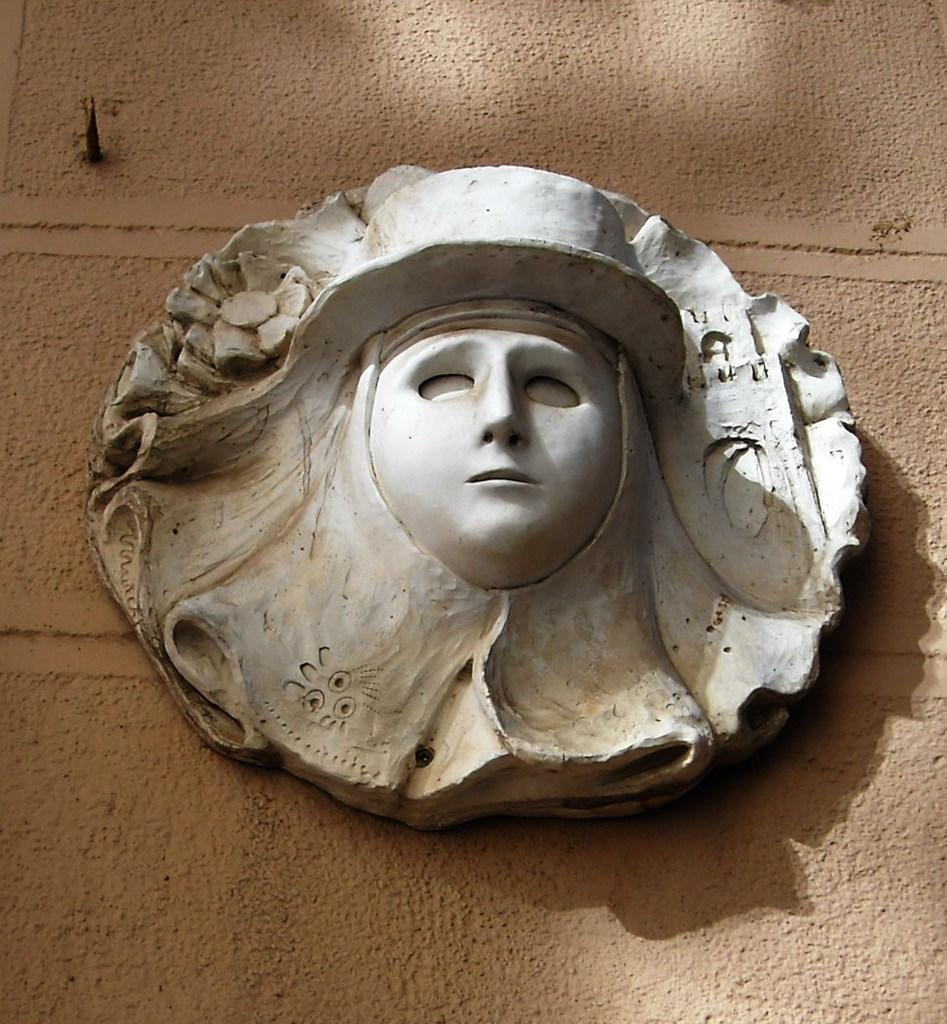Could you give a brief overview of what you see in this image? In this picture I can observe a sculpture on the wall. 